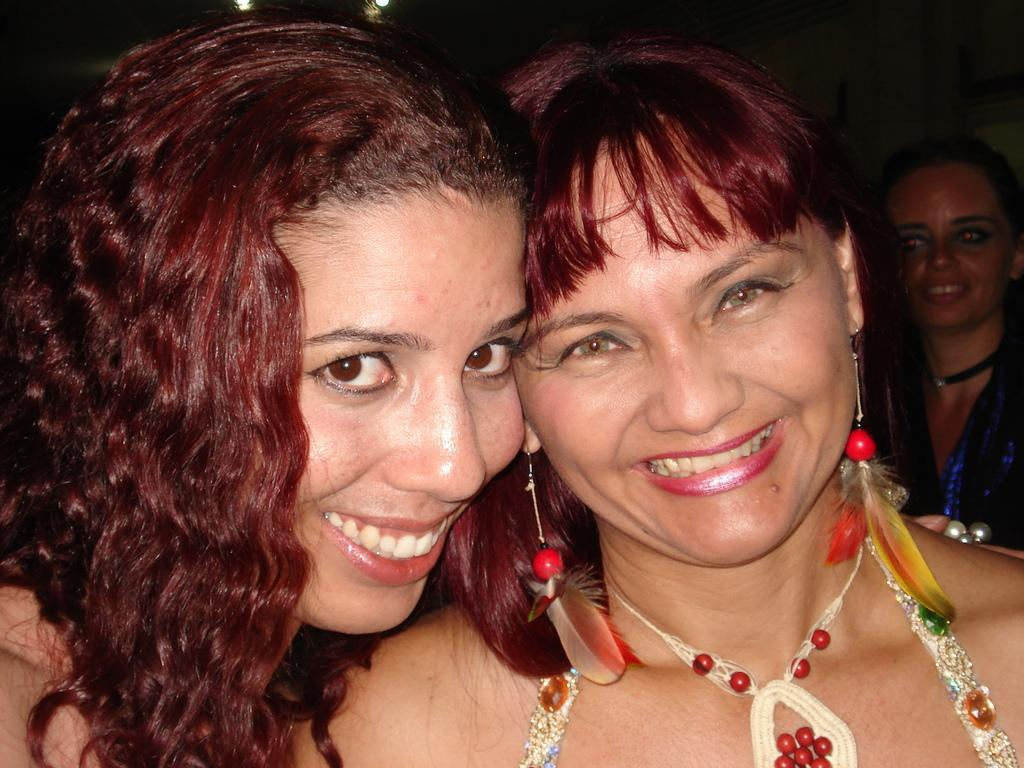How many women are present in the image? There are two women in the image. What is the facial expression of the women? Both women are smiling. Can you describe the accessories worn by one of the women? One of the women is wearing earrings and a necklace. Is there anyone else visible in the image? Yes, there is another woman smiling in the background of the image. What type of caption is written on the image? There is no caption present in the image; it is a photograph of the women. 